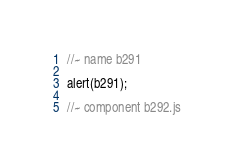<code> <loc_0><loc_0><loc_500><loc_500><_JavaScript_>//~ name b291

alert(b291);

//~ component b292.js

</code> 